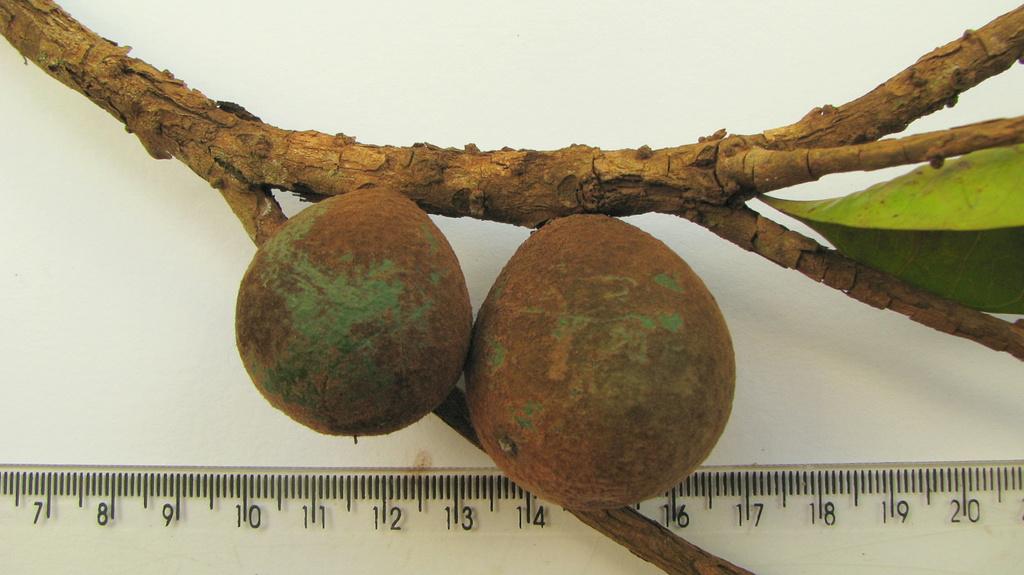What is the lowest number shown on the ruler?
Give a very brief answer. 7. What is the highest number?
Provide a short and direct response. 20. 